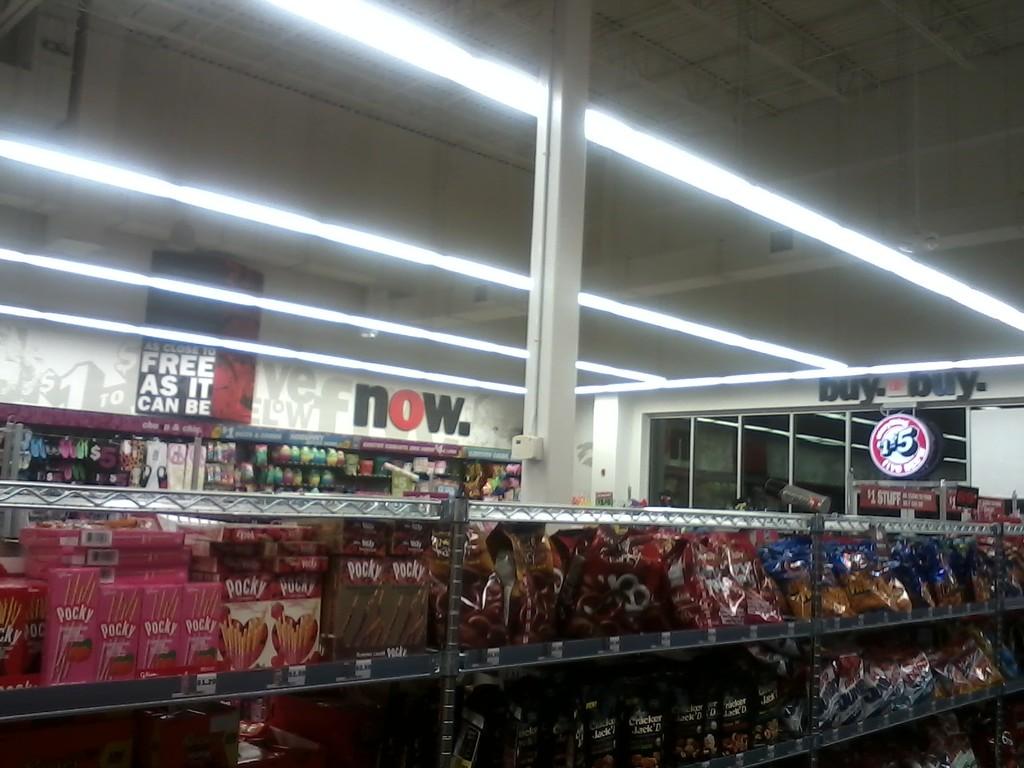When does the words say in the back of the store?
Your answer should be very brief. Now. 